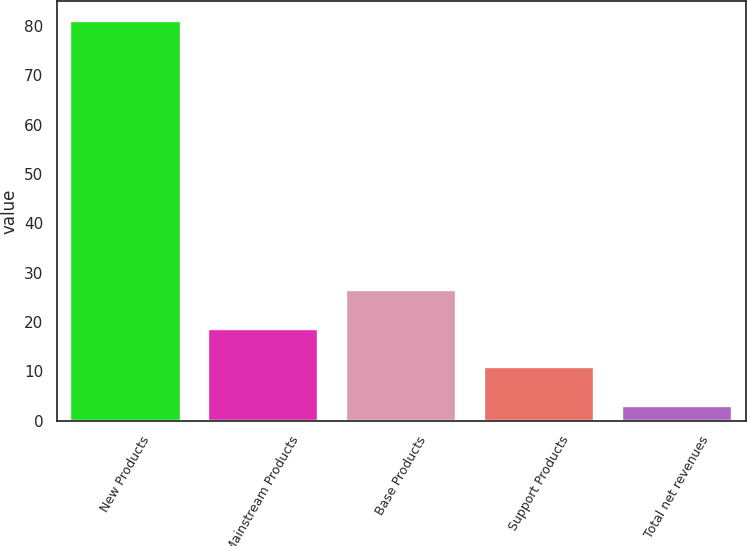<chart> <loc_0><loc_0><loc_500><loc_500><bar_chart><fcel>New Products<fcel>Mainstream Products<fcel>Base Products<fcel>Support Products<fcel>Total net revenues<nl><fcel>81<fcel>18.6<fcel>26.4<fcel>10.8<fcel>3<nl></chart> 